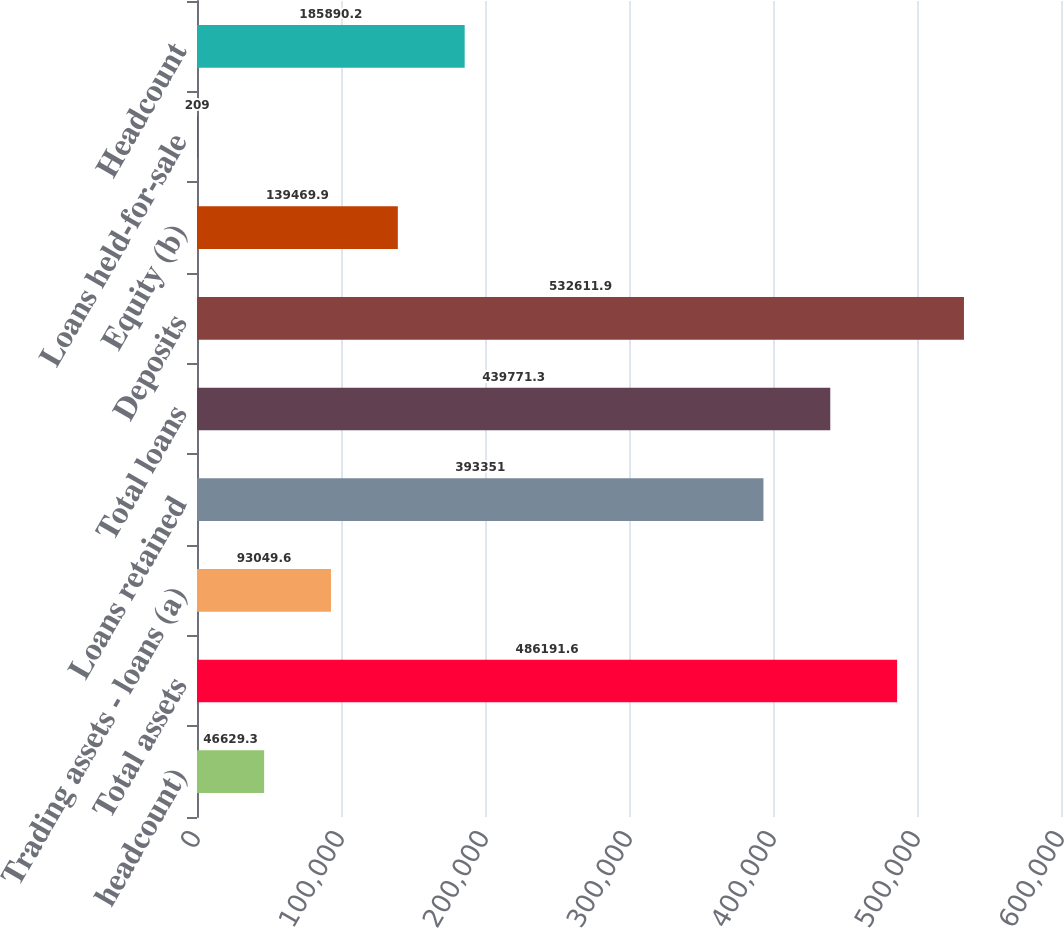Convert chart. <chart><loc_0><loc_0><loc_500><loc_500><bar_chart><fcel>headcount)<fcel>Total assets<fcel>Trading assets - loans (a)<fcel>Loans retained<fcel>Total loans<fcel>Deposits<fcel>Equity (b)<fcel>Loans held-for-sale<fcel>Headcount<nl><fcel>46629.3<fcel>486192<fcel>93049.6<fcel>393351<fcel>439771<fcel>532612<fcel>139470<fcel>209<fcel>185890<nl></chart> 